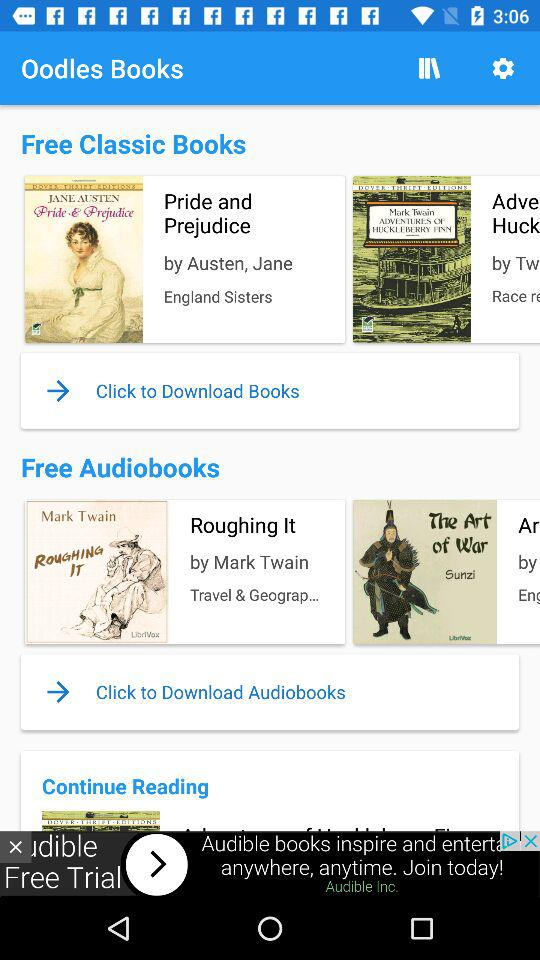Who are Austen and Jane?
When the provided information is insufficient, respond with <no answer>. <no answer> 